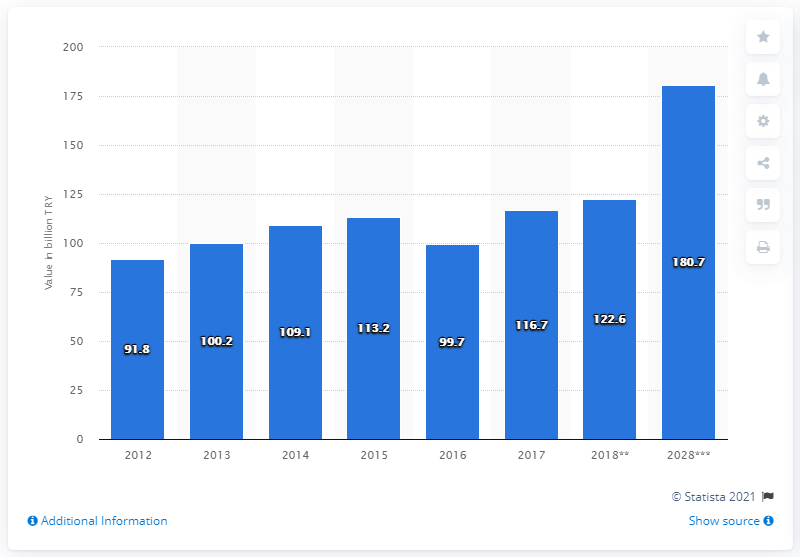Draw attention to some important aspects in this diagram. The direct contribution of the travel and tourism industry to GDP in Turkey decreased in 2016. In 2017, the direct contribution of the travel and tourism industry to Turkey's GDP was 116.7%. 